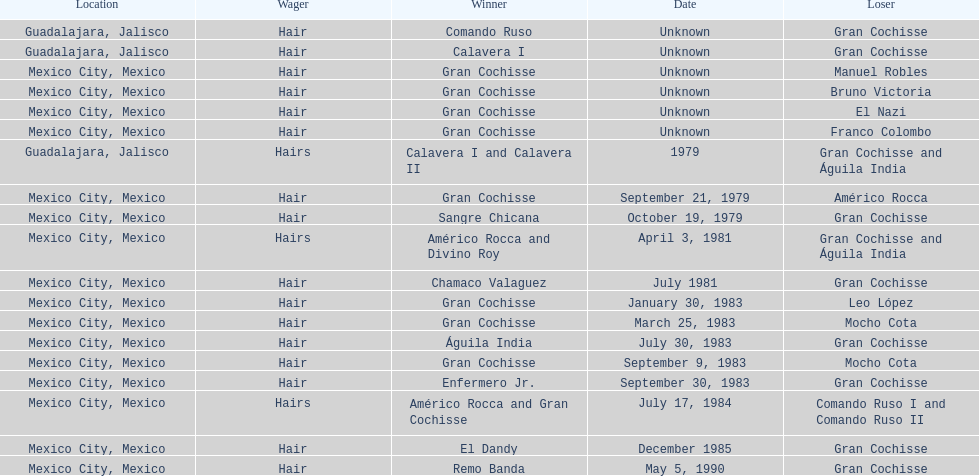What was the number of losses gran cochisse had against el dandy? 1. Give me the full table as a dictionary. {'header': ['Location', 'Wager', 'Winner', 'Date', 'Loser'], 'rows': [['Guadalajara, Jalisco', 'Hair', 'Comando Ruso', 'Unknown', 'Gran Cochisse'], ['Guadalajara, Jalisco', 'Hair', 'Calavera I', 'Unknown', 'Gran Cochisse'], ['Mexico City, Mexico', 'Hair', 'Gran Cochisse', 'Unknown', 'Manuel Robles'], ['Mexico City, Mexico', 'Hair', 'Gran Cochisse', 'Unknown', 'Bruno Victoria'], ['Mexico City, Mexico', 'Hair', 'Gran Cochisse', 'Unknown', 'El Nazi'], ['Mexico City, Mexico', 'Hair', 'Gran Cochisse', 'Unknown', 'Franco Colombo'], ['Guadalajara, Jalisco', 'Hairs', 'Calavera I and Calavera II', '1979', 'Gran Cochisse and Águila India'], ['Mexico City, Mexico', 'Hair', 'Gran Cochisse', 'September 21, 1979', 'Américo Rocca'], ['Mexico City, Mexico', 'Hair', 'Sangre Chicana', 'October 19, 1979', 'Gran Cochisse'], ['Mexico City, Mexico', 'Hairs', 'Américo Rocca and Divino Roy', 'April 3, 1981', 'Gran Cochisse and Águila India'], ['Mexico City, Mexico', 'Hair', 'Chamaco Valaguez', 'July 1981', 'Gran Cochisse'], ['Mexico City, Mexico', 'Hair', 'Gran Cochisse', 'January 30, 1983', 'Leo López'], ['Mexico City, Mexico', 'Hair', 'Gran Cochisse', 'March 25, 1983', 'Mocho Cota'], ['Mexico City, Mexico', 'Hair', 'Águila India', 'July 30, 1983', 'Gran Cochisse'], ['Mexico City, Mexico', 'Hair', 'Gran Cochisse', 'September 9, 1983', 'Mocho Cota'], ['Mexico City, Mexico', 'Hair', 'Enfermero Jr.', 'September 30, 1983', 'Gran Cochisse'], ['Mexico City, Mexico', 'Hairs', 'Américo Rocca and Gran Cochisse', 'July 17, 1984', 'Comando Ruso I and Comando Ruso II'], ['Mexico City, Mexico', 'Hair', 'El Dandy', 'December 1985', 'Gran Cochisse'], ['Mexico City, Mexico', 'Hair', 'Remo Banda', 'May 5, 1990', 'Gran Cochisse']]} 